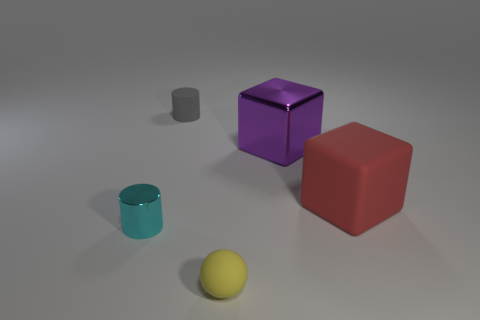Is the number of tiny gray things left of the small gray rubber cylinder the same as the number of rubber balls that are left of the cyan cylinder?
Your answer should be compact. Yes. Do the small matte object that is in front of the tiny cyan shiny cylinder and the big rubber thing have the same shape?
Offer a terse response. No. What number of red objects are either large shiny objects or small rubber cylinders?
Offer a terse response. 0. What is the material of the other thing that is the same shape as the cyan object?
Your answer should be very brief. Rubber. The small thing behind the cyan object has what shape?
Keep it short and to the point. Cylinder. Are there any big purple cubes that have the same material as the cyan cylinder?
Give a very brief answer. Yes. Do the red matte block and the purple cube have the same size?
Your response must be concise. Yes. How many spheres are cyan things or small things?
Give a very brief answer. 1. How many large red objects have the same shape as the small gray object?
Provide a short and direct response. 0. Is the number of small cyan cylinders in front of the purple thing greater than the number of matte cubes to the left of the gray cylinder?
Your response must be concise. Yes. 